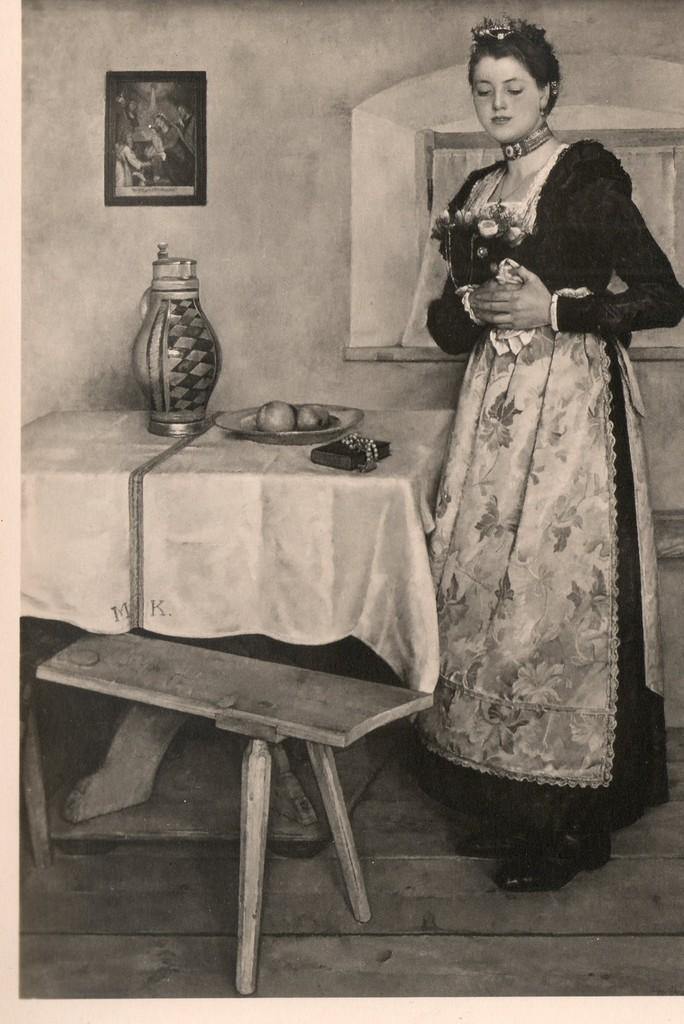How would you summarize this image in a sentence or two? This is a black and white picture. Here we can see a woman standing on the floor. There are tables. On the table there is a cloth, plate, fruits, and a jug. In the background we can see a wall and a frame. 